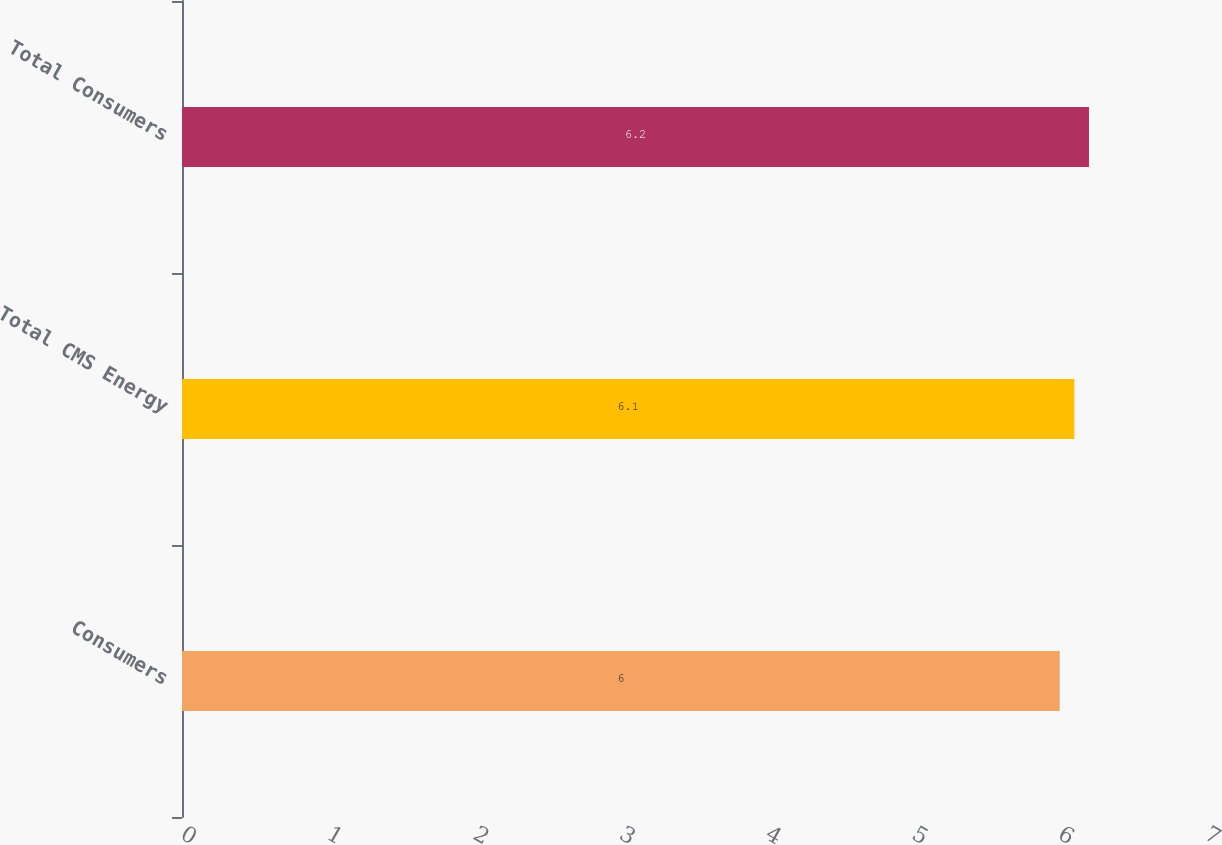<chart> <loc_0><loc_0><loc_500><loc_500><bar_chart><fcel>Consumers<fcel>Total CMS Energy<fcel>Total Consumers<nl><fcel>6<fcel>6.1<fcel>6.2<nl></chart> 